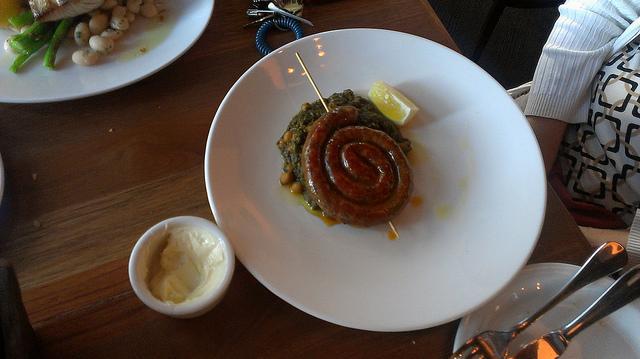What condiment is in the small white container next to the dish? butter 